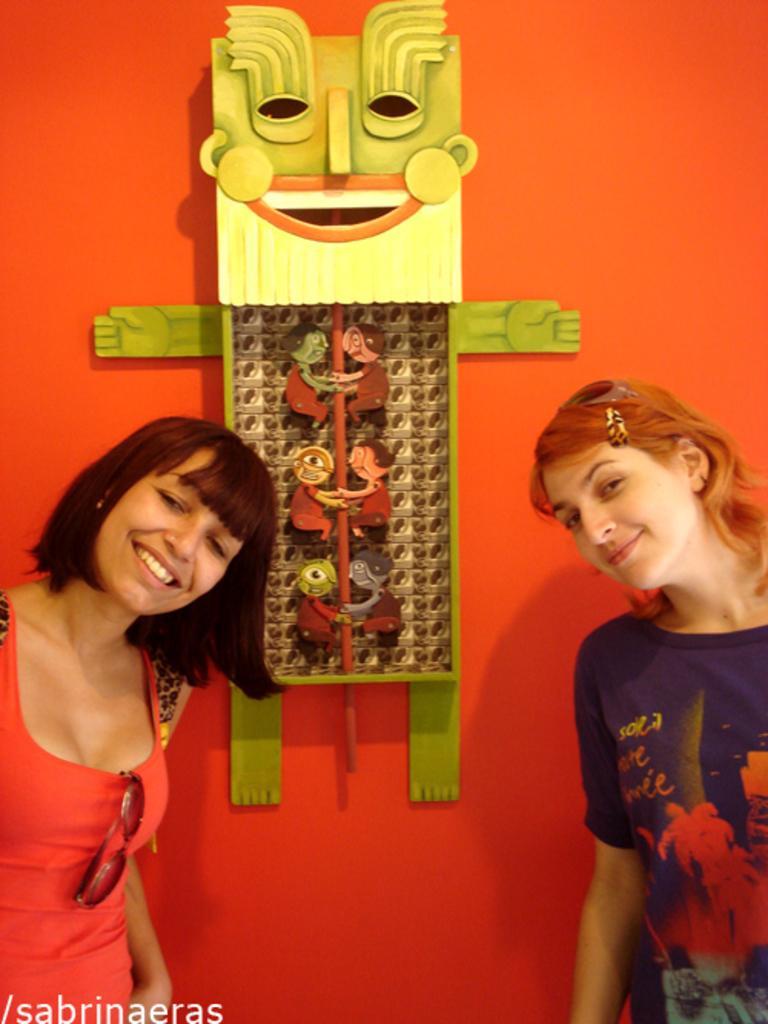How would you summarize this image in a sentence or two? On the right and left side of the image we can women. In the background there is wall hanging and wall. 